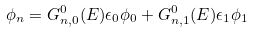Convert formula to latex. <formula><loc_0><loc_0><loc_500><loc_500>\phi _ { n } = G _ { n , 0 } ^ { 0 } ( E ) \epsilon _ { 0 } \phi _ { 0 } + G _ { n , 1 } ^ { 0 } ( E ) \epsilon _ { 1 } \phi _ { 1 }</formula> 